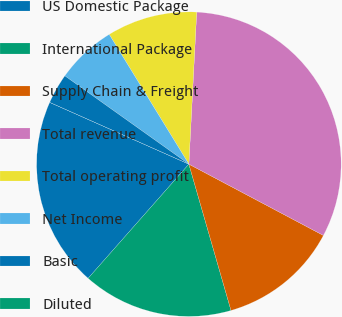<chart> <loc_0><loc_0><loc_500><loc_500><pie_chart><fcel>US Domestic Package<fcel>International Package<fcel>Supply Chain & Freight<fcel>Total revenue<fcel>Total operating profit<fcel>Net Income<fcel>Basic<fcel>Diluted<nl><fcel>20.14%<fcel>15.97%<fcel>12.78%<fcel>31.94%<fcel>9.58%<fcel>6.39%<fcel>3.2%<fcel>0.0%<nl></chart> 